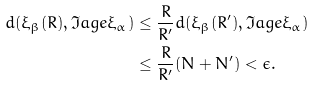<formula> <loc_0><loc_0><loc_500><loc_500>d ( \xi _ { \beta } ( R ) , \Im a g e \xi _ { \alpha } ) & \leq \frac { R } { R ^ { \prime } } d ( \xi _ { \beta } ( R ^ { \prime } ) , \Im a g e \xi _ { \alpha } ) \\ & \leq \frac { R } { R ^ { \prime } } ( N + N ^ { \prime } ) < \epsilon .</formula> 